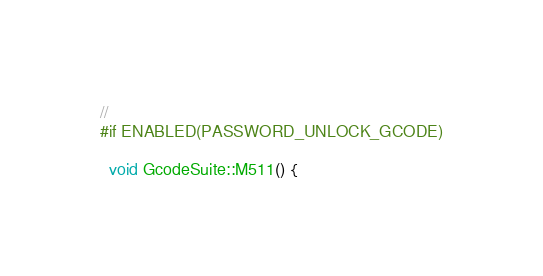Convert code to text. <code><loc_0><loc_0><loc_500><loc_500><_C++_>//
#if ENABLED(PASSWORD_UNLOCK_GCODE)

  void GcodeSuite::M511() {</code> 